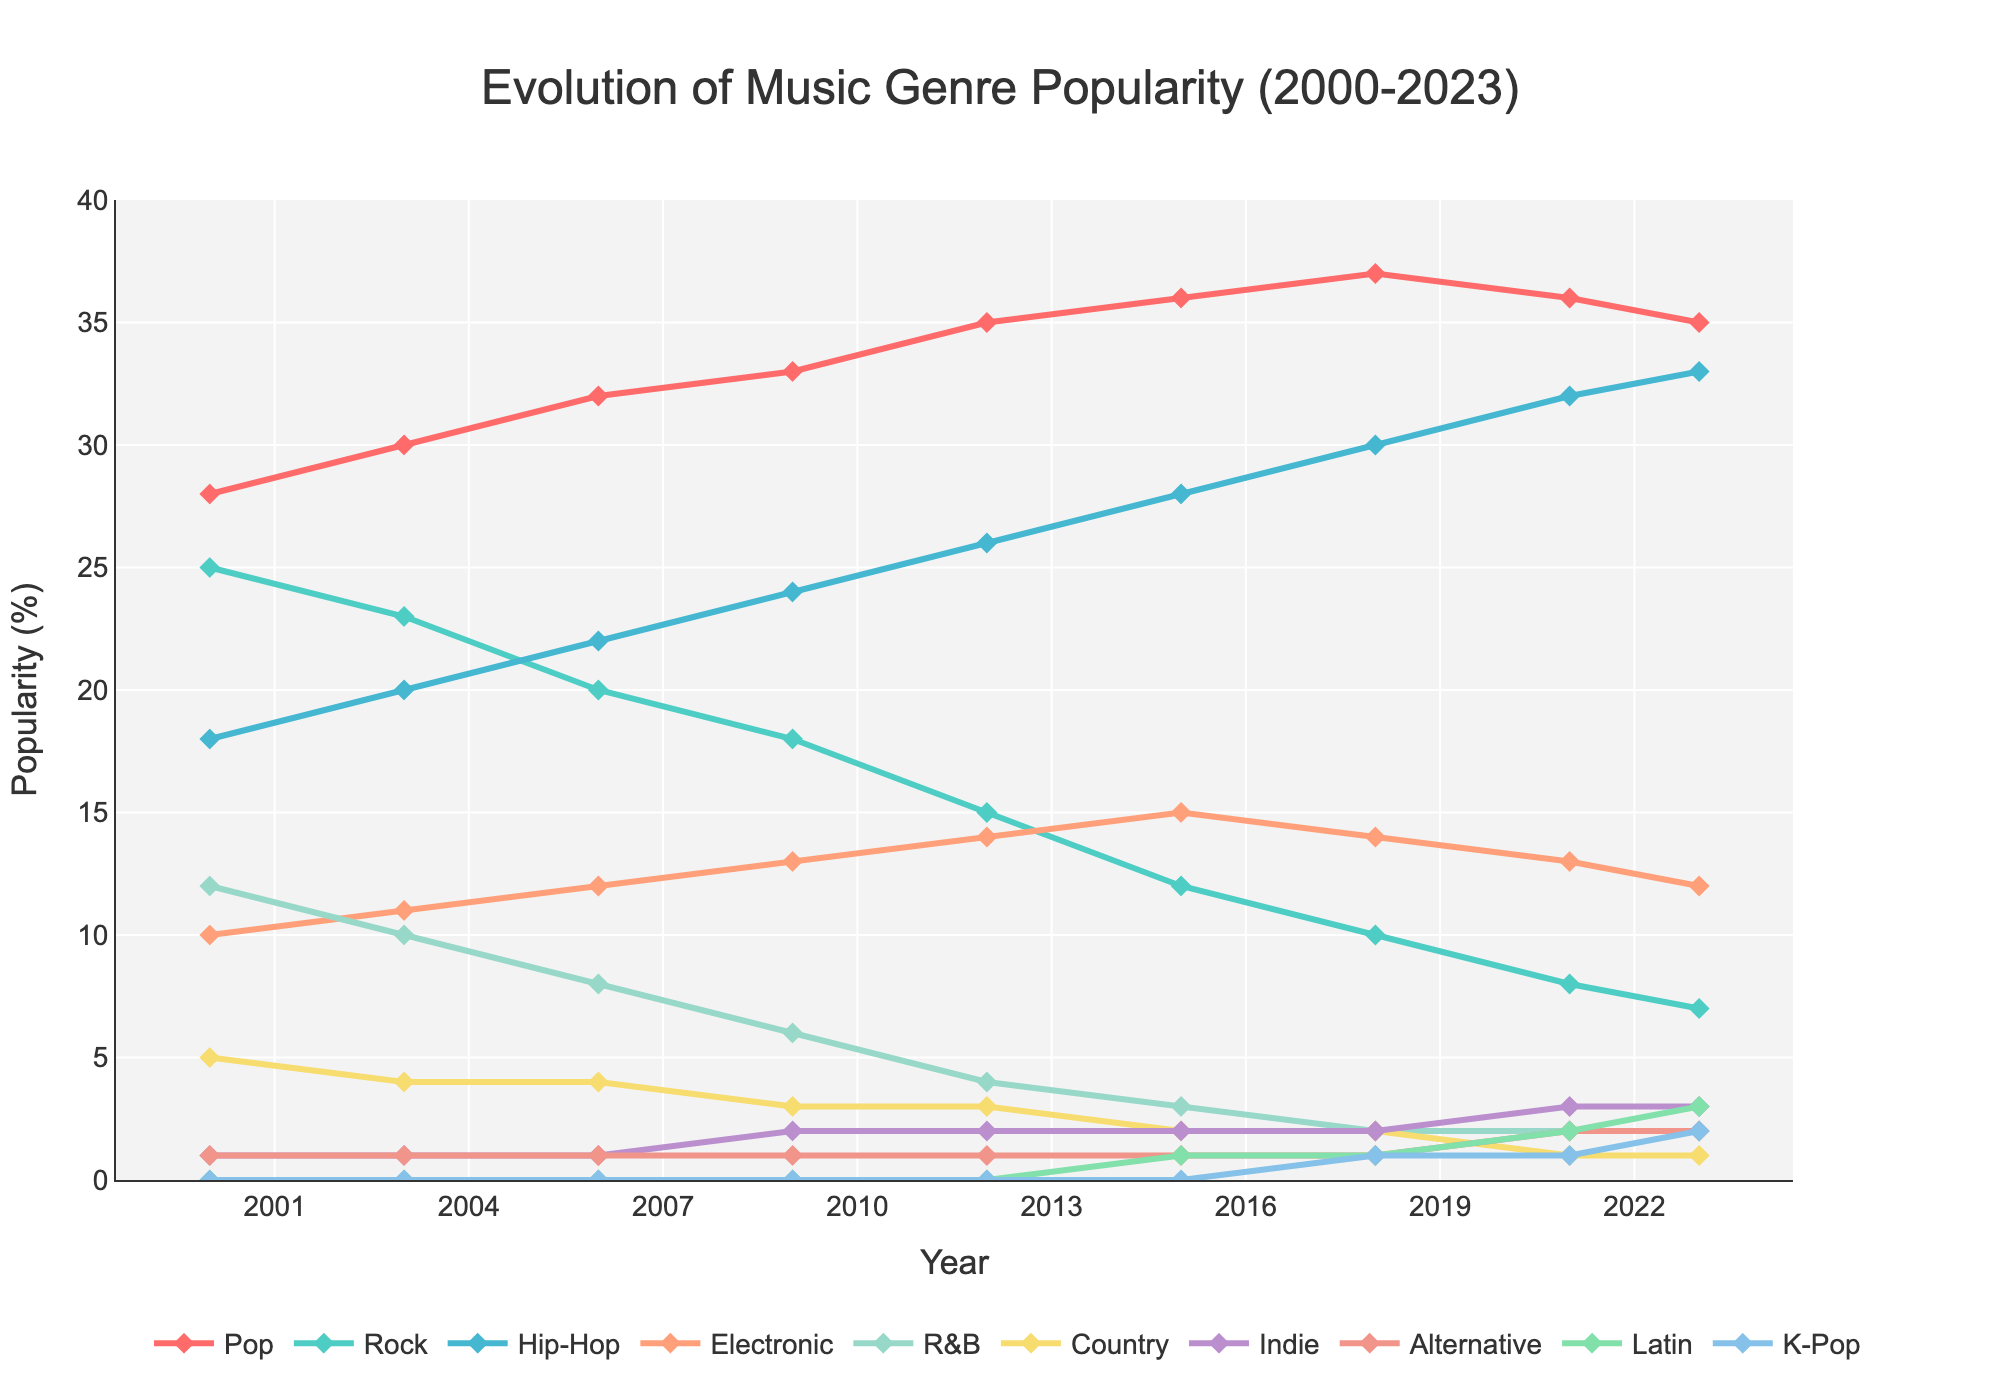What year did Hip-Hop surpass Rock in popularity? In 2006, Hip-Hop's popularity is 22% while Rock's popularity is 20%, thus Hip-Hop surpassing Rock for the first time.
Answer: 2006 Which genre had the highest gain in popularity from 2000 to 2023? Hip-Hop increased from 18% in 2000 to 33% in 2023, which is a maximum increase of 15%. Comparisons with other genres show they had lesser increases.
Answer: Hip-Hop How has the popularity of the Rock genre changed from 2000 to 2023? In 2000, Rock was at 25%, and it gradually declined each year until it reached 7% in 2023.
Answer: Decreased Which two years did Pop music's popularity peak at its highest value in the dataset? Pop music's popularity reached its highest at 37% in both 2018 and 2015 according to the graph.
Answer: 2018 and 2015 From 2000 to 2023, which genres emerged and became more popular? Indie, Alternative, Latin, and K-Pop were not present or negligible in 2000 but have appeared and increased to 3%, 2%, 3%, and 2% shares, respectively, by 2023.
Answer: Indie, Alternative, Latin, K-Pop What was the difference in popularity of R&B music between 2000 and 2023? R&B's popularity decreased from 12% in 2000 to 2% in 2023, a difference of 10%.
Answer: 10% During which year did the genre 'Alternative' first appear on the graph? Alternative music appears on the graph beginning in 2009, with a value of 1%.
Answer: 2009 By how much did Electronic music's popularity change from 2000 to its peak year? Electronic music started at 10% in 2000 and peaked at 15% in 2015, representing an increase of 5%.
Answer: 5% In 2023, which genre had the lowest popularity and what was its percentage? In 2023, the genre with the lowest popularity is Country at 1%.
Answer: Country, 1% 